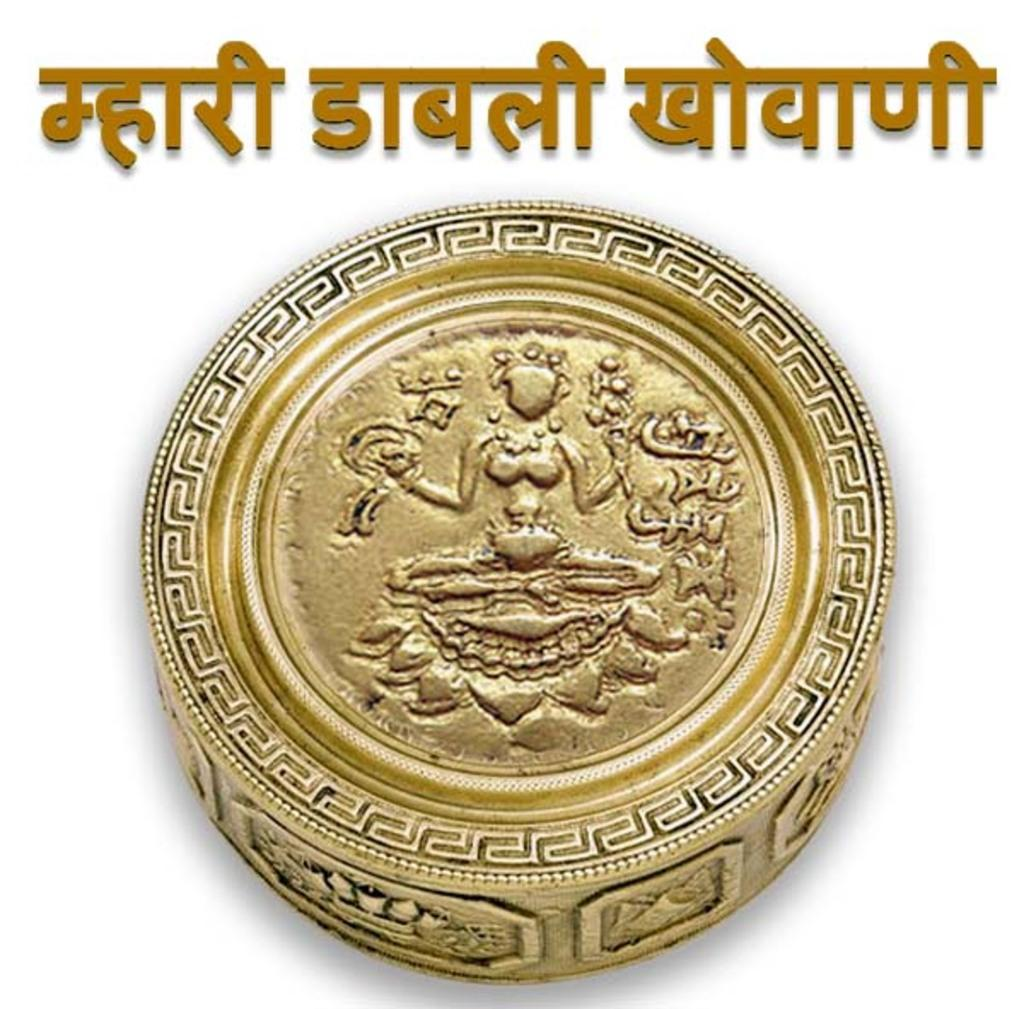What is the main object in the image? There is a gold-colored coin in the image. What language is used in the text in the image? The text in the image is in Hindi. How many rabbits are visible in the image? There are no rabbits present in the image. What type of bath can be seen in the image? There is no bath present in the image. 